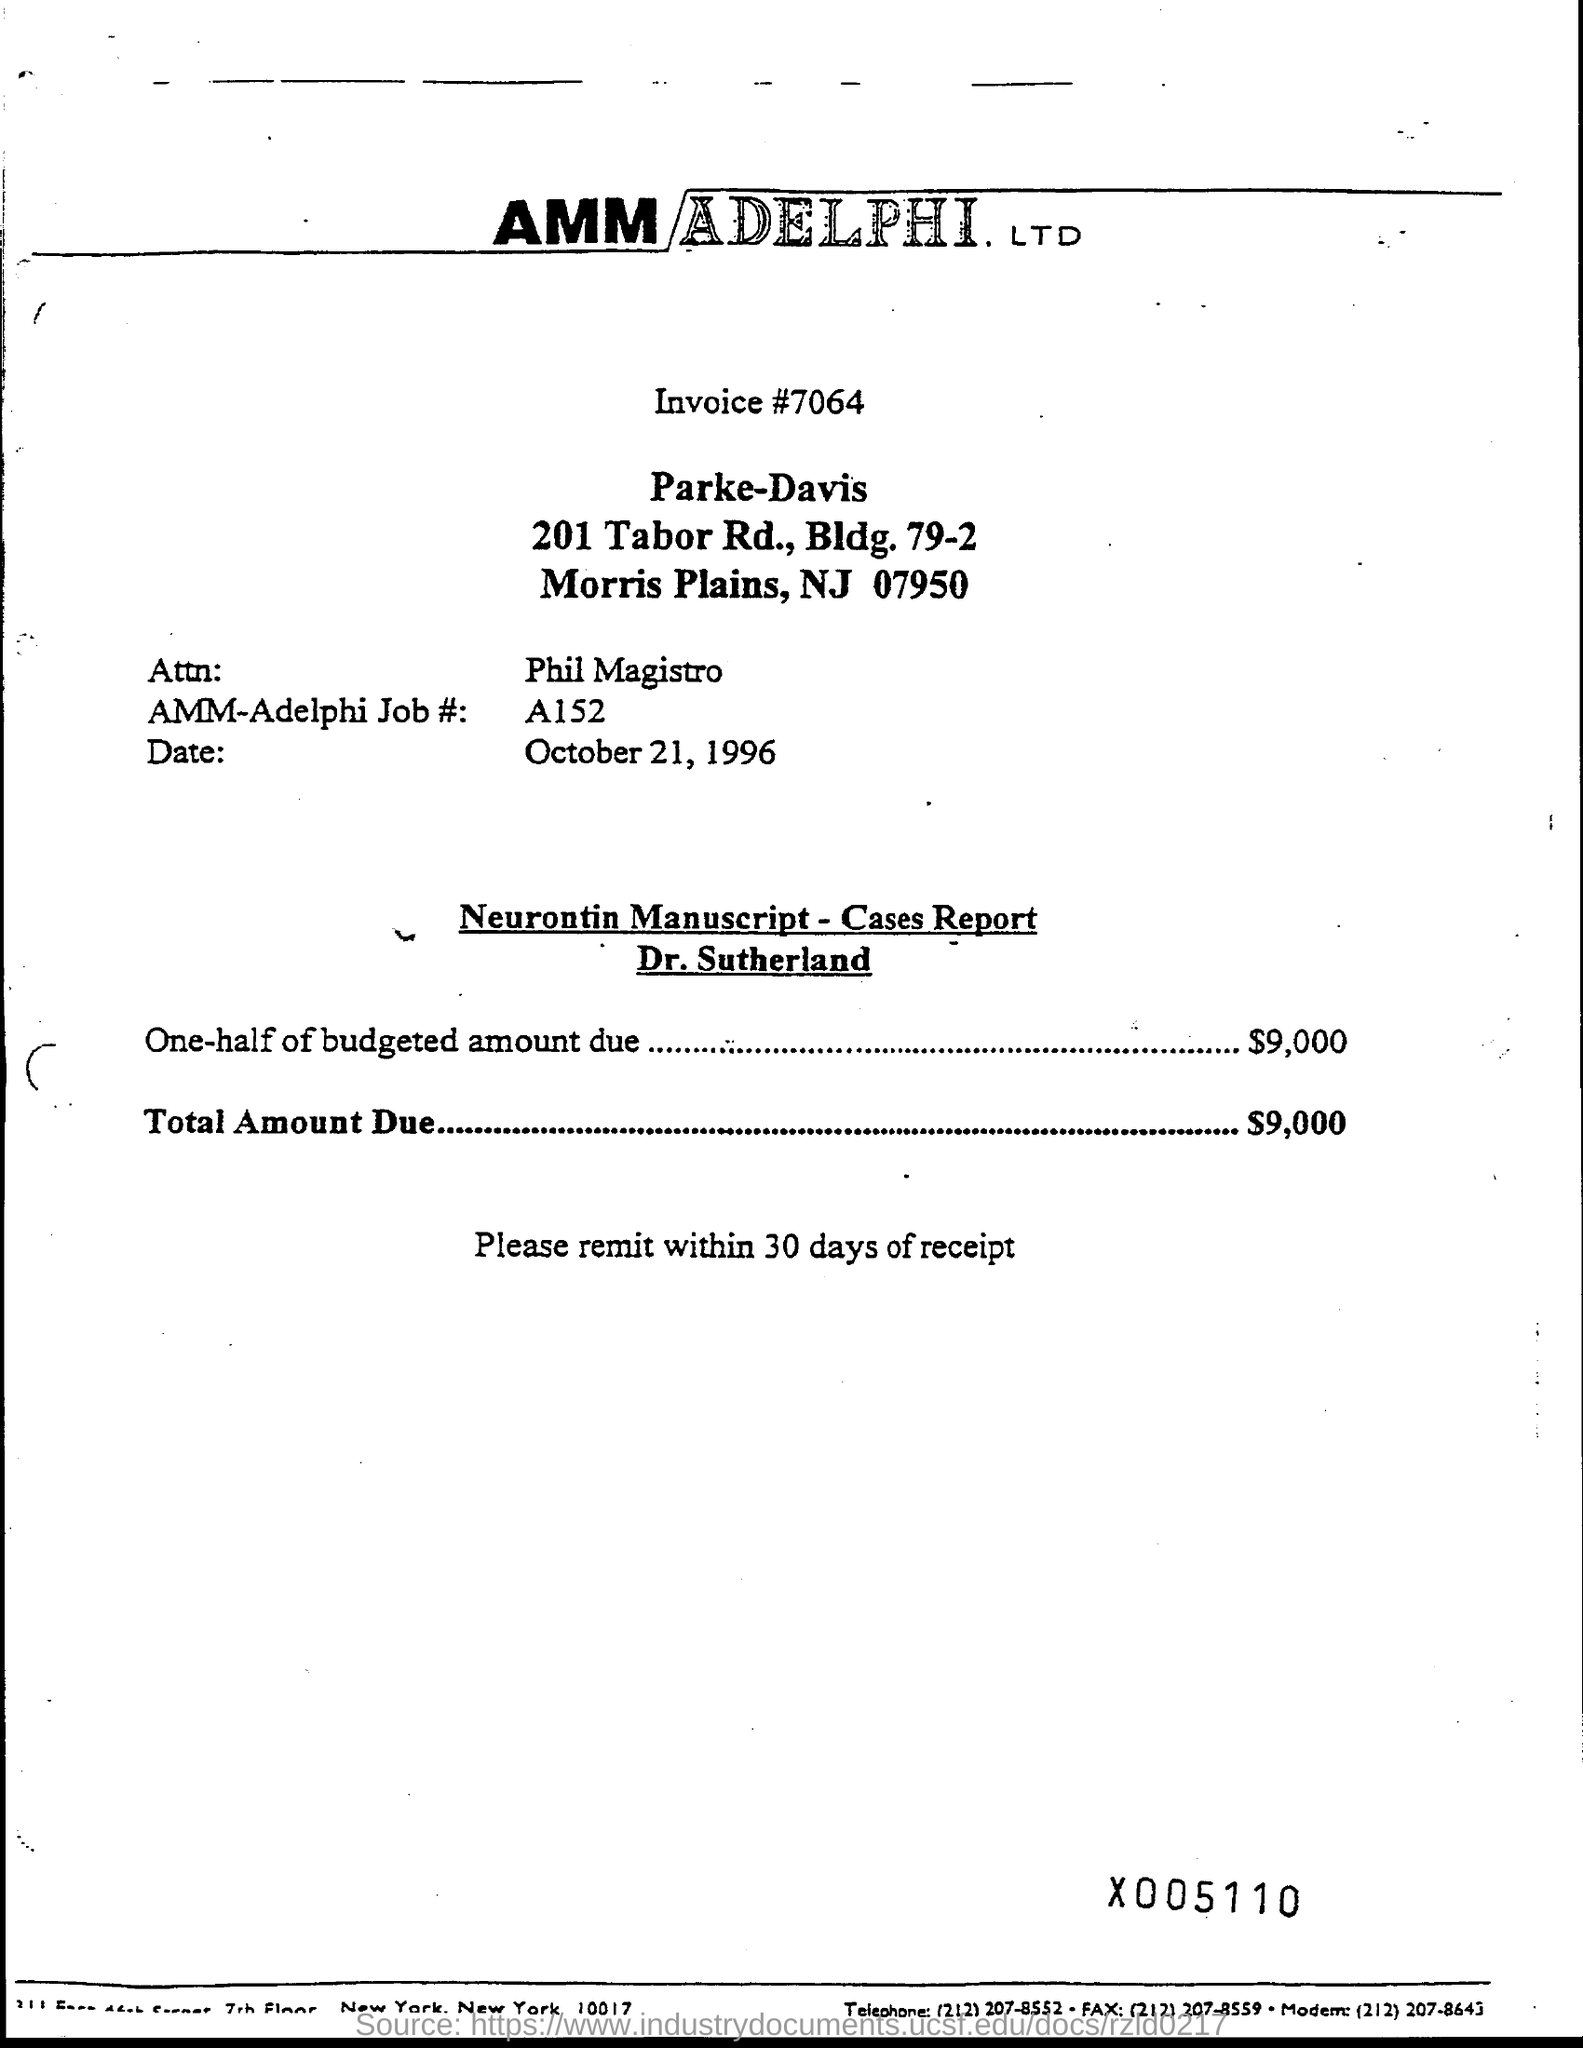What is the invoice # ?
Ensure brevity in your answer.  7064. What is the name of attn?
Keep it short and to the point. PHIL MAGISTRO. What is the date mentioned in document?
Keep it short and to the point. OCTOBER 21, 1996. What is the total amount due ?
Offer a very short reply. $9,000. 